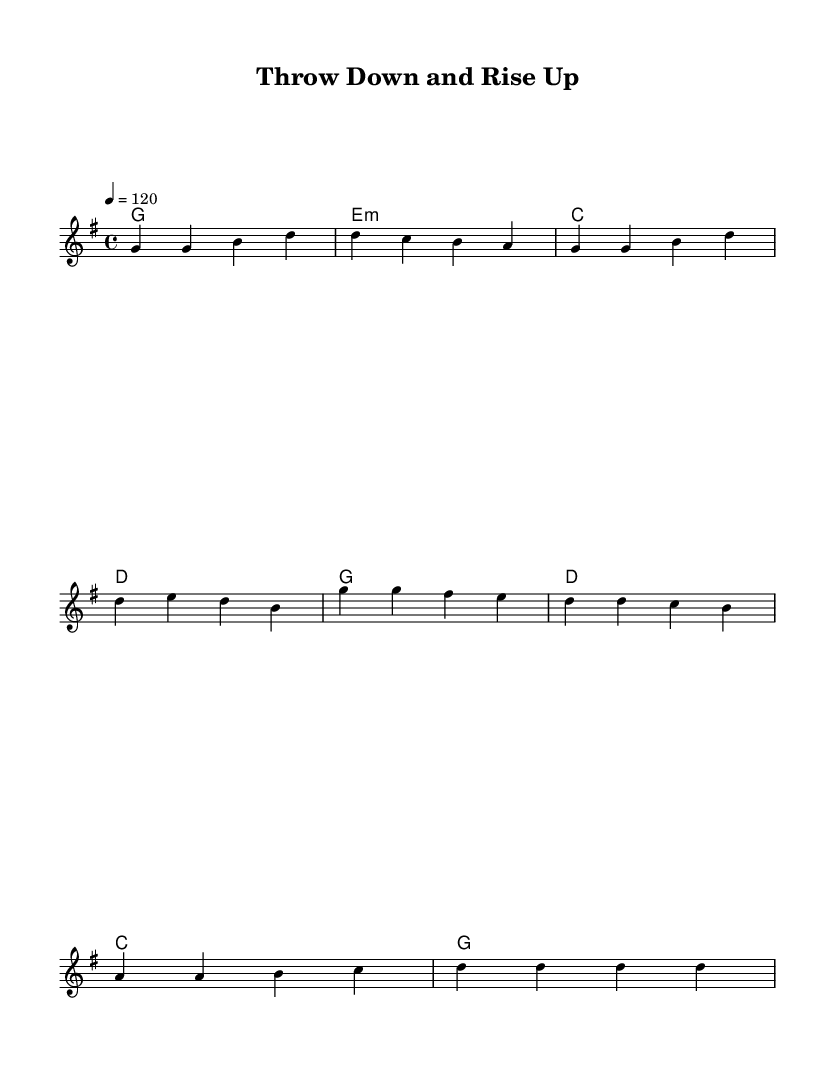What is the key signature of this music? The key signature is G major, which has one sharp, F#. This can be identified by looking at the key signature indicator at the beginning of the staff.
Answer: G major What is the time signature of the piece? The time signature is 4/4, indicated at the beginning of the score. 4/4 means there are four beats in each measure, and the quarter note gets one beat.
Answer: 4/4 What is the tempo marking for this piece? The tempo marking is 120 beats per minute, indicated as "4 = 120." This shows the speed at which the music should be played.
Answer: 120 How many measures are in the verse section? The verse section contains four measures, indicated by the grouping of notes below the stanza of lyrics for the verse. Each line of music corresponds to one measure.
Answer: 4 What is the first word of the chorus? The first word of the chorus is "Throw," found at the beginning of the chorus lyrics. This shows the thematic initiation of the uplifting message of the song.
Answer: Throw In which sport does the song's theme center? The song's theme centers around judo, as indicated by the mention of "judo spirit" in the chorus lyrics. This reflects the perseverance and challenges associated with this martial art.
Answer: Judo How do the lyrics reflect the theme of perseverance? The lyrics express perseverance through phrases like "rise again after each fall" and "never gonna give up," emphasizing resilience and determination in the face of challenges in sports.
Answer: Resilience 